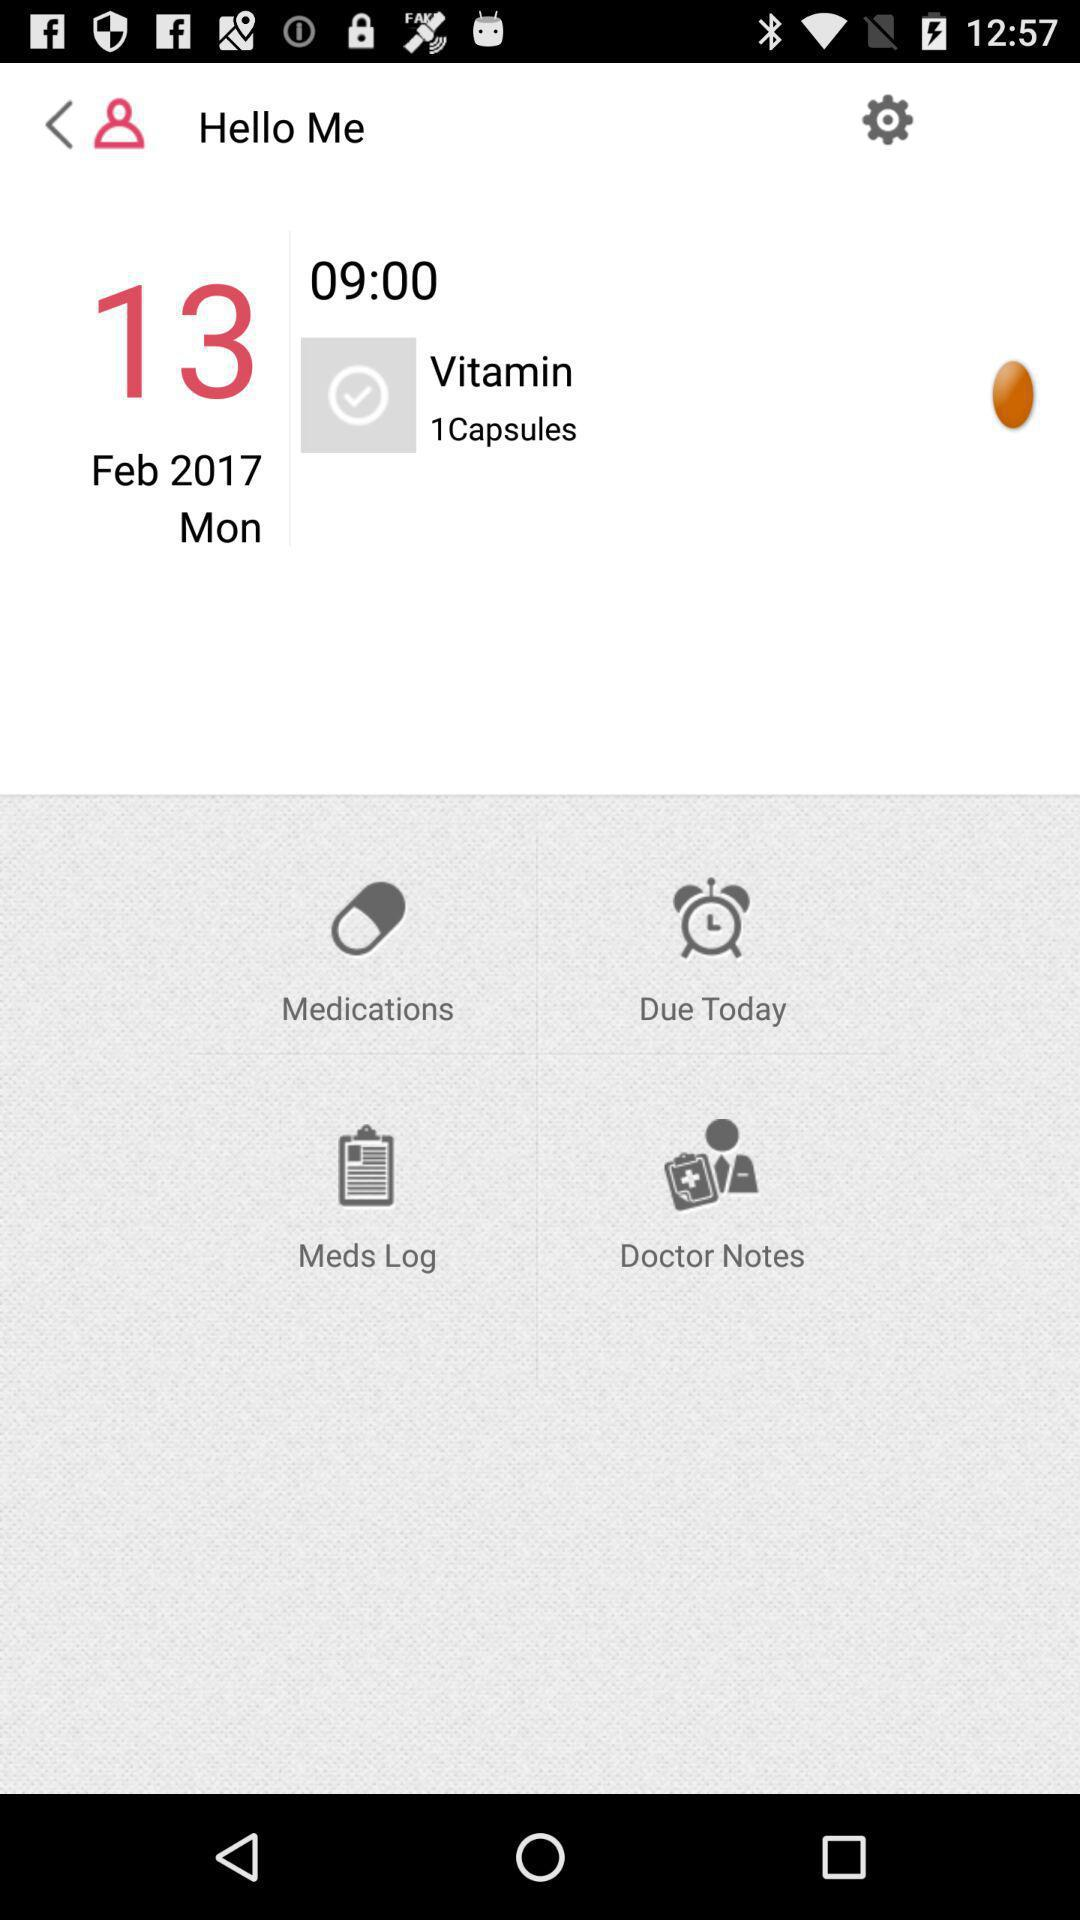How many capsules of vitamins have to be taken? You have to take one capsule. 